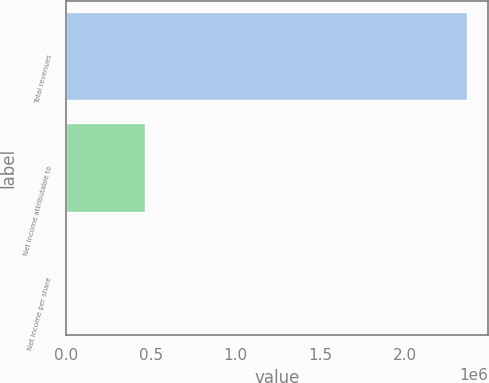<chart> <loc_0><loc_0><loc_500><loc_500><bar_chart><fcel>Total revenues<fcel>Net income attributable to<fcel>Net income per share<nl><fcel>2.37592e+06<fcel>475187<fcel>2.76<nl></chart> 